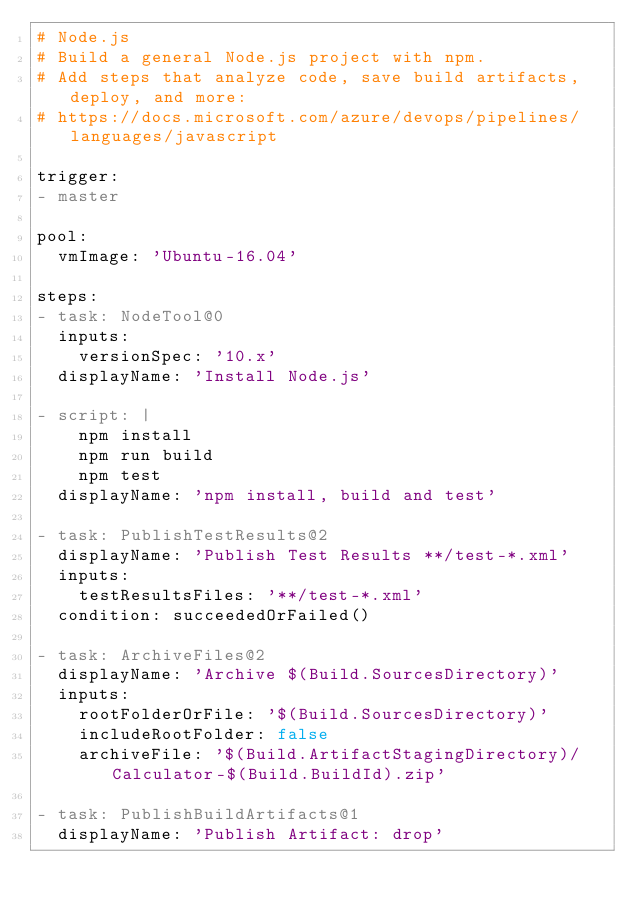Convert code to text. <code><loc_0><loc_0><loc_500><loc_500><_YAML_># Node.js
# Build a general Node.js project with npm.
# Add steps that analyze code, save build artifacts, deploy, and more:
# https://docs.microsoft.com/azure/devops/pipelines/languages/javascript

trigger:
- master

pool:
  vmImage: 'Ubuntu-16.04'

steps:
- task: NodeTool@0
  inputs:
    versionSpec: '10.x'
  displayName: 'Install Node.js'

- script: |
    npm install
    npm run build
    npm test
  displayName: 'npm install, build and test'

- task: PublishTestResults@2
  displayName: 'Publish Test Results **/test-*.xml'
  inputs:
    testResultsFiles: '**/test-*.xml'
  condition: succeededOrFailed()

- task: ArchiveFiles@2
  displayName: 'Archive $(Build.SourcesDirectory)'
  inputs:
    rootFolderOrFile: '$(Build.SourcesDirectory)'
    includeRootFolder: false
    archiveFile: '$(Build.ArtifactStagingDirectory)/Calculator-$(Build.BuildId).zip'

- task: PublishBuildArtifacts@1
  displayName: 'Publish Artifact: drop'
</code> 